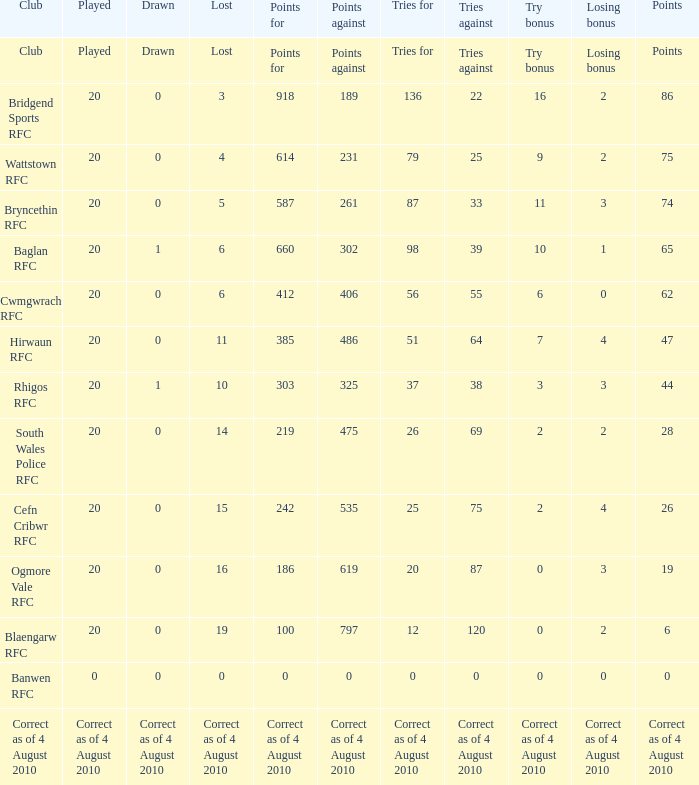What is the point tally for the blaengarw rfc club? 6.0. 